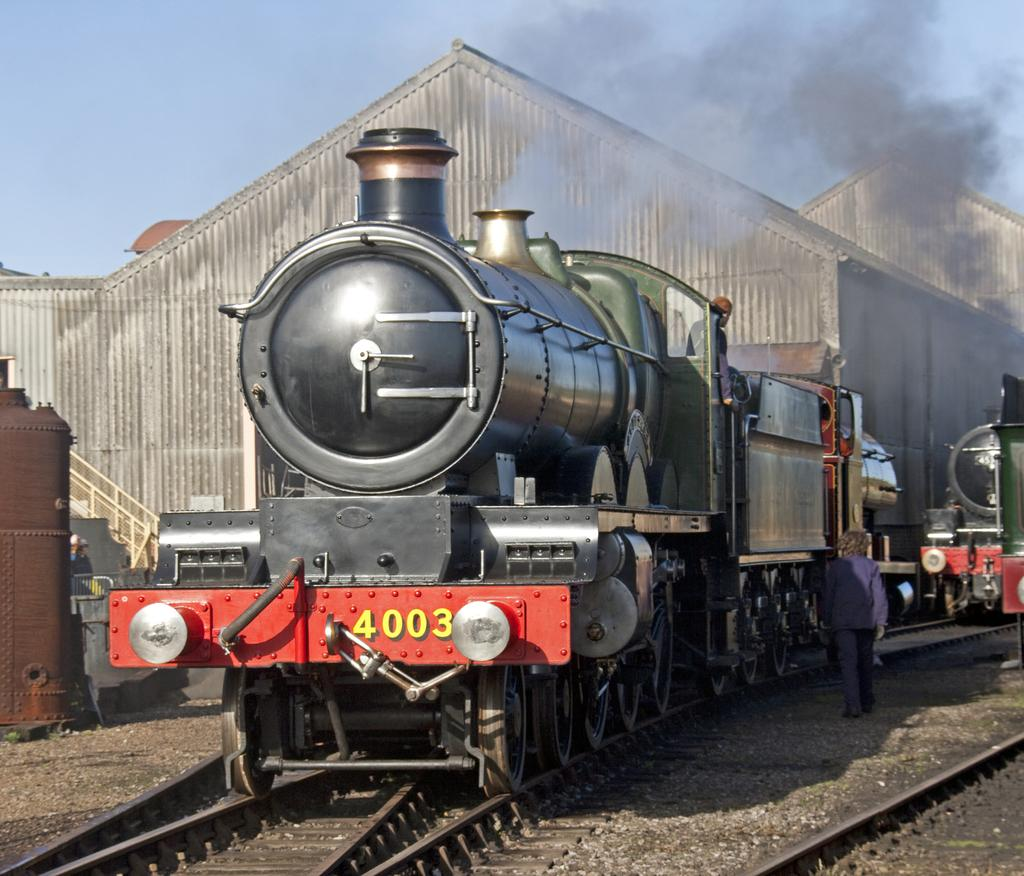What is the person in the image doing? There is a person walking in the image. What can be seen on the ground in the image? There are trains on tracks in the image. What is the source of the smoke visible in the image? The source of the smoke is not specified, but it could be related to the trains or other activities in the image. What type of structures can be seen in the background of the image? There are sheds in the background of the image. What is visible in the sky in the image? The sky is visible in the background of the image. What type of seed is the owl holding in its beak in the image? There is no owl or seed present in the image. What event is taking place in the image? The image does not depict a specific event; it shows a person walking, trains on tracks, smoke, sheds, and the sky. 